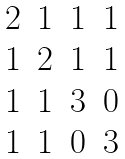<formula> <loc_0><loc_0><loc_500><loc_500>\begin{matrix} 2 & 1 & 1 & 1 \\ 1 & 2 & 1 & 1 \\ 1 & 1 & 3 & 0 \\ 1 & 1 & 0 & 3 \end{matrix}</formula> 